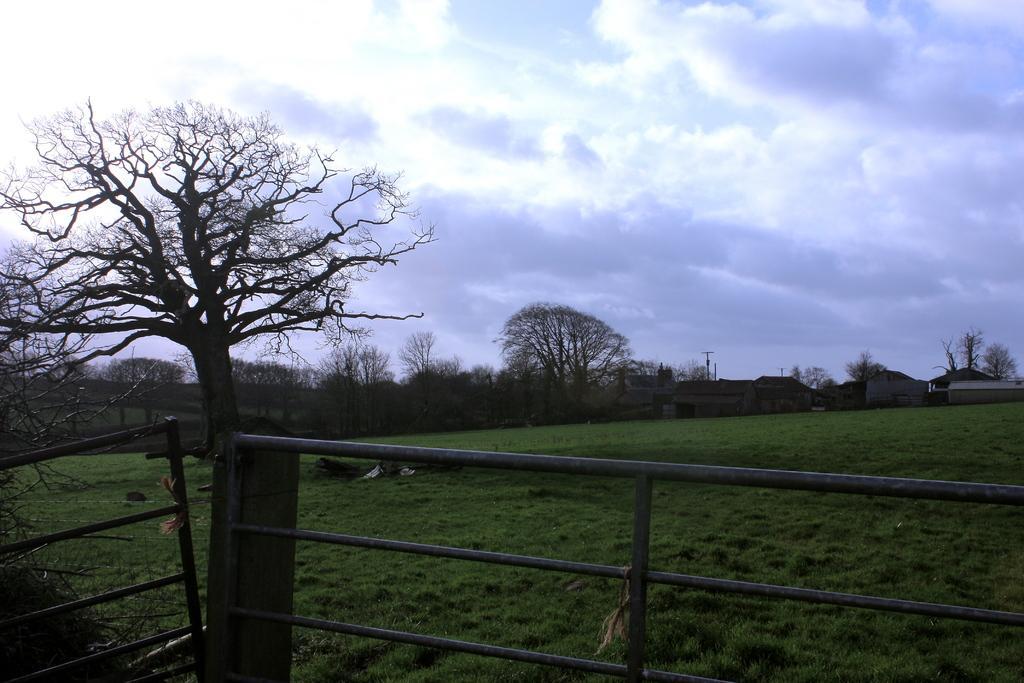In one or two sentences, can you explain what this image depicts? There is an iron fence. In the background, there are trees, buildings and grass on the ground and there are clouds in the sky. 